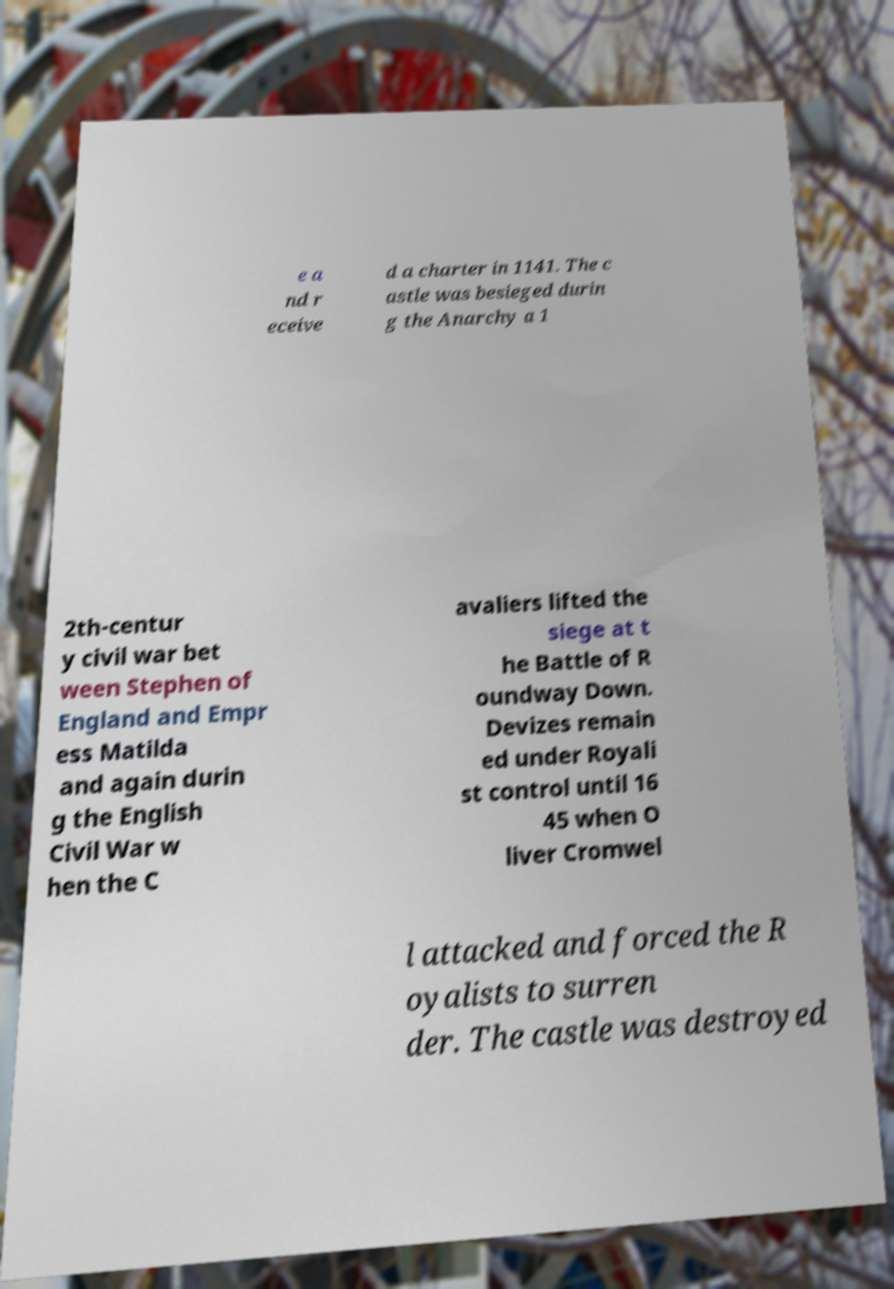Please identify and transcribe the text found in this image. e a nd r eceive d a charter in 1141. The c astle was besieged durin g the Anarchy a 1 2th-centur y civil war bet ween Stephen of England and Empr ess Matilda and again durin g the English Civil War w hen the C avaliers lifted the siege at t he Battle of R oundway Down. Devizes remain ed under Royali st control until 16 45 when O liver Cromwel l attacked and forced the R oyalists to surren der. The castle was destroyed 